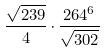Convert formula to latex. <formula><loc_0><loc_0><loc_500><loc_500>\frac { \sqrt { 2 3 9 } } { 4 } \cdot \frac { 2 6 4 ^ { 6 } } { \sqrt { 3 0 2 } }</formula> 